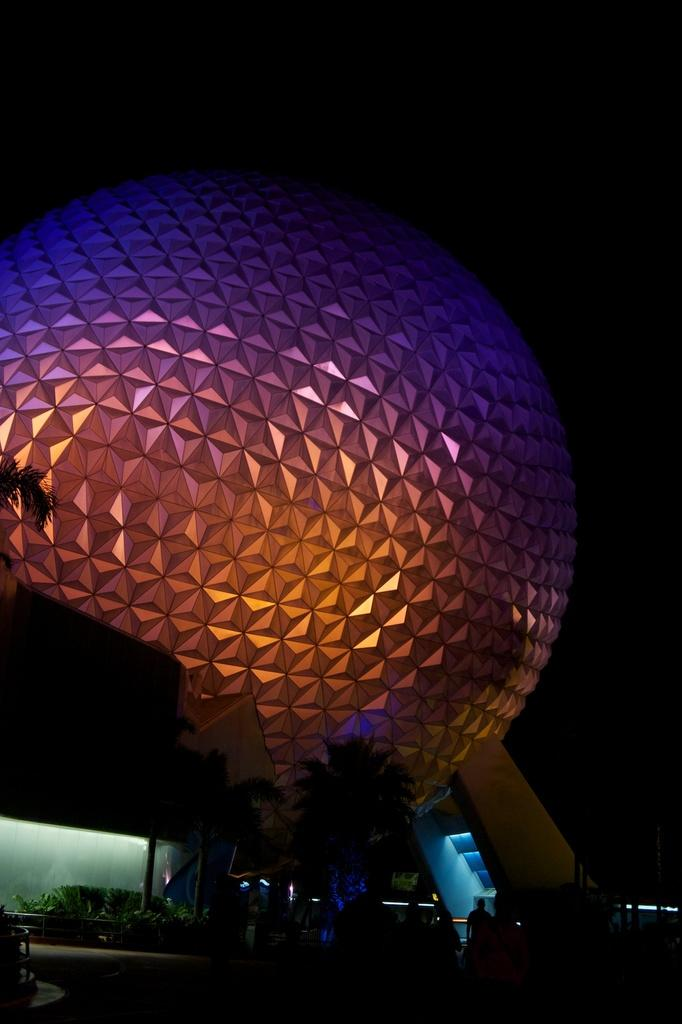What type of vegetation can be seen in the image? There are trees in the image. What type of scene is visible in the background of the image? There is an agricultural scene in the background of the image. How would you describe the overall appearance of the image? The image has a dark appearance. What type of cheese is being used to create the snake in the image? There is no cheese or snake present in the image. 